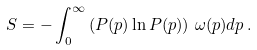<formula> <loc_0><loc_0><loc_500><loc_500>S = - \int _ { 0 } ^ { \infty } \left ( P ( p ) \ln P ( p ) \right ) \, \omega ( p ) d p \, .</formula> 